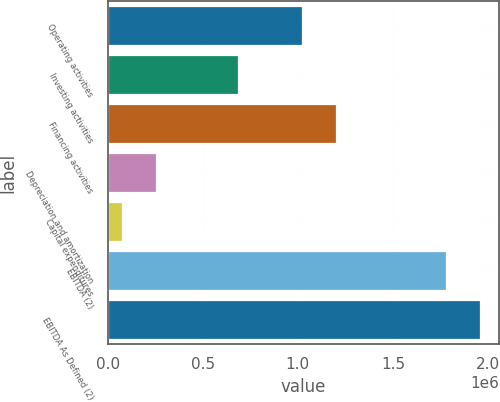Convert chart. <chart><loc_0><loc_0><loc_500><loc_500><bar_chart><fcel>Operating activities<fcel>Investing activities<fcel>Financing activities<fcel>Depreciation and amortization<fcel>Capital expenditures<fcel>EBITDA (2)<fcel>EBITDA As Defined (2)<nl><fcel>1.02217e+06<fcel>683577<fcel>1.20249e+06<fcel>253663<fcel>73341<fcel>1.77841e+06<fcel>1.95873e+06<nl></chart> 